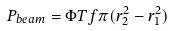<formula> <loc_0><loc_0><loc_500><loc_500>P _ { b e a m } = \Phi T f \pi ( r _ { 2 } ^ { 2 } - r _ { 1 } ^ { 2 } )</formula> 